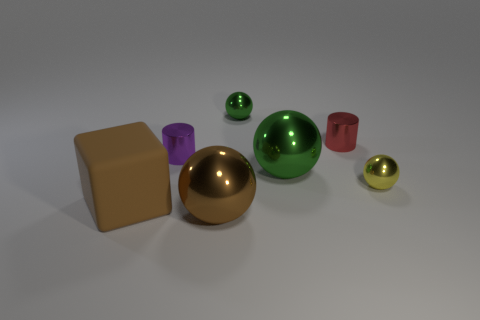There is a tiny red object; is it the same shape as the metallic thing to the right of the red cylinder?
Provide a short and direct response. No. Are there any spheres that have the same material as the big block?
Give a very brief answer. No. There is a large ball that is behind the small shiny ball that is in front of the small green metallic object; is there a green metallic thing that is on the left side of it?
Give a very brief answer. Yes. How many other things are the same shape as the tiny red shiny object?
Provide a succinct answer. 1. What color is the metal cylinder that is to the right of the green metallic object that is on the left side of the big shiny thing that is behind the large rubber object?
Make the answer very short. Red. What number of tiny yellow shiny spheres are there?
Your response must be concise. 1. What number of tiny objects are either cylinders or red things?
Provide a short and direct response. 2. The red shiny thing that is the same size as the purple shiny thing is what shape?
Provide a short and direct response. Cylinder. Is there any other thing that has the same size as the red metal thing?
Make the answer very short. Yes. There is a cylinder that is left of the sphere that is in front of the big rubber object; what is it made of?
Provide a short and direct response. Metal. 